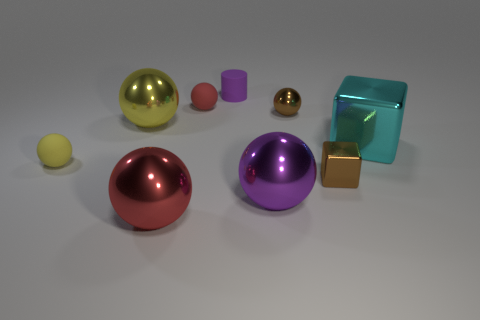Are there fewer small brown shiny objects that are on the left side of the big red thing than large purple balls that are on the left side of the small red object?
Provide a short and direct response. No. There is a purple thing to the right of the matte cylinder; what size is it?
Make the answer very short. Large. Do the yellow rubber ball and the cylinder have the same size?
Offer a terse response. Yes. How many rubber things are both behind the tiny metallic ball and on the left side of the purple rubber cylinder?
Offer a terse response. 1. What number of blue objects are rubber spheres or metal cubes?
Offer a terse response. 0. How many rubber things are either small gray objects or large cyan blocks?
Offer a very short reply. 0. Is there a brown object?
Provide a short and direct response. Yes. Is the tiny yellow object the same shape as the big purple metal thing?
Ensure brevity in your answer.  Yes. How many small rubber objects are to the right of the brown metal object behind the large yellow metallic object left of the big red thing?
Offer a very short reply. 0. What material is the large object that is behind the purple metal sphere and on the left side of the small cylinder?
Give a very brief answer. Metal. 